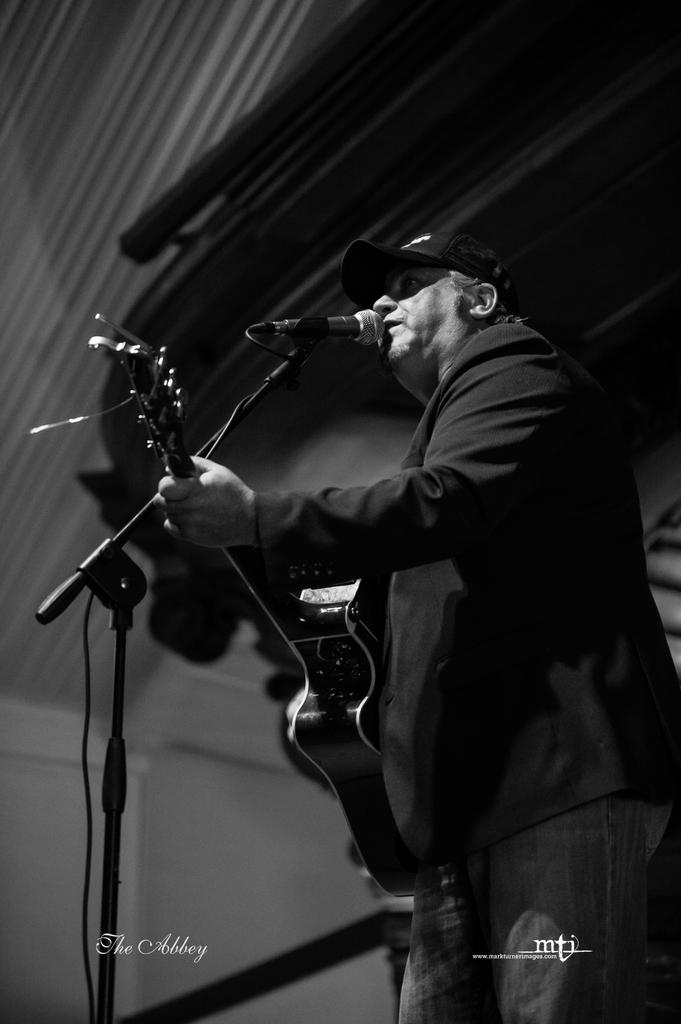What is the color scheme of the image? The image is black and white. Who is the main subject in the image? There is a man in the image. What is the man doing in the image? The man is singing and playing a guitar. What object is the man holding in the image? The man is holding a microphone. What line does the man have to decide whether to cross in the image? There is no line present in the image, and therefore no decision to make about crossing it. 